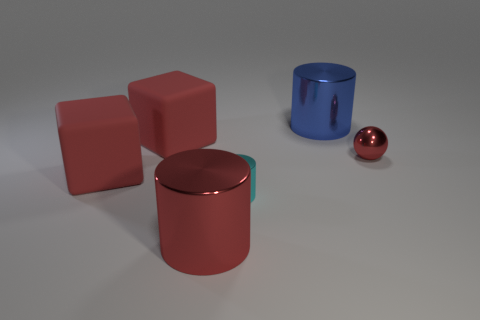Add 1 big red metallic cylinders. How many objects exist? 7 Subtract all spheres. How many objects are left? 5 Add 1 small cyan cylinders. How many small cyan cylinders exist? 2 Subtract 0 purple cylinders. How many objects are left? 6 Subtract all tiny spheres. Subtract all big cylinders. How many objects are left? 3 Add 1 red cubes. How many red cubes are left? 3 